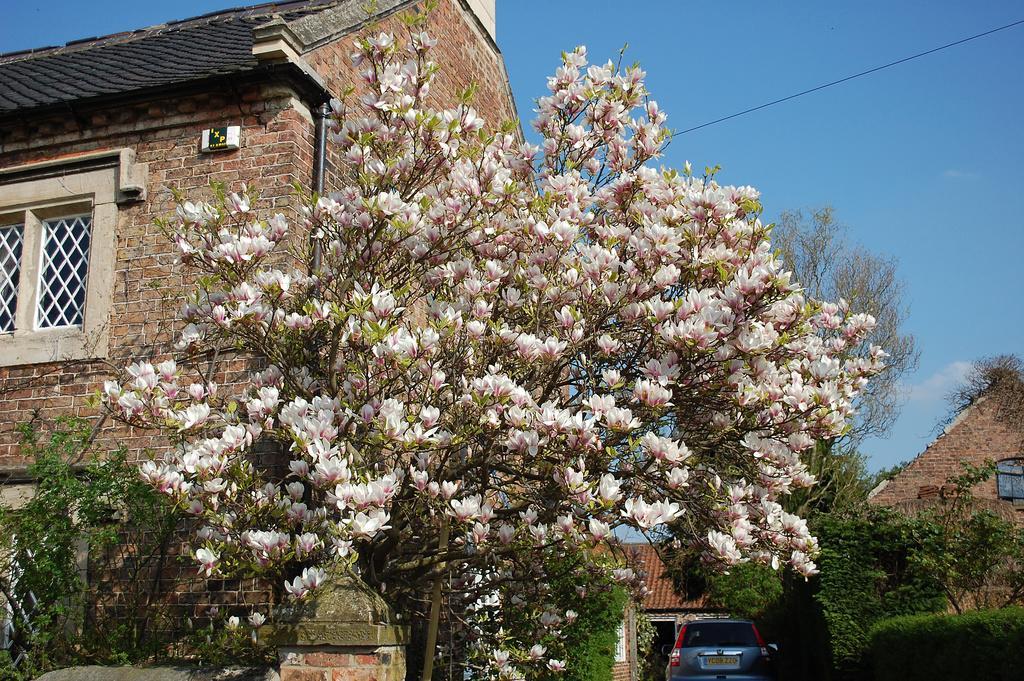How would you summarize this image in a sentence or two? In the center of the image there is a tree with flowers. In the background of the image there is a house,sky. At the bottom of the image there is a car. 